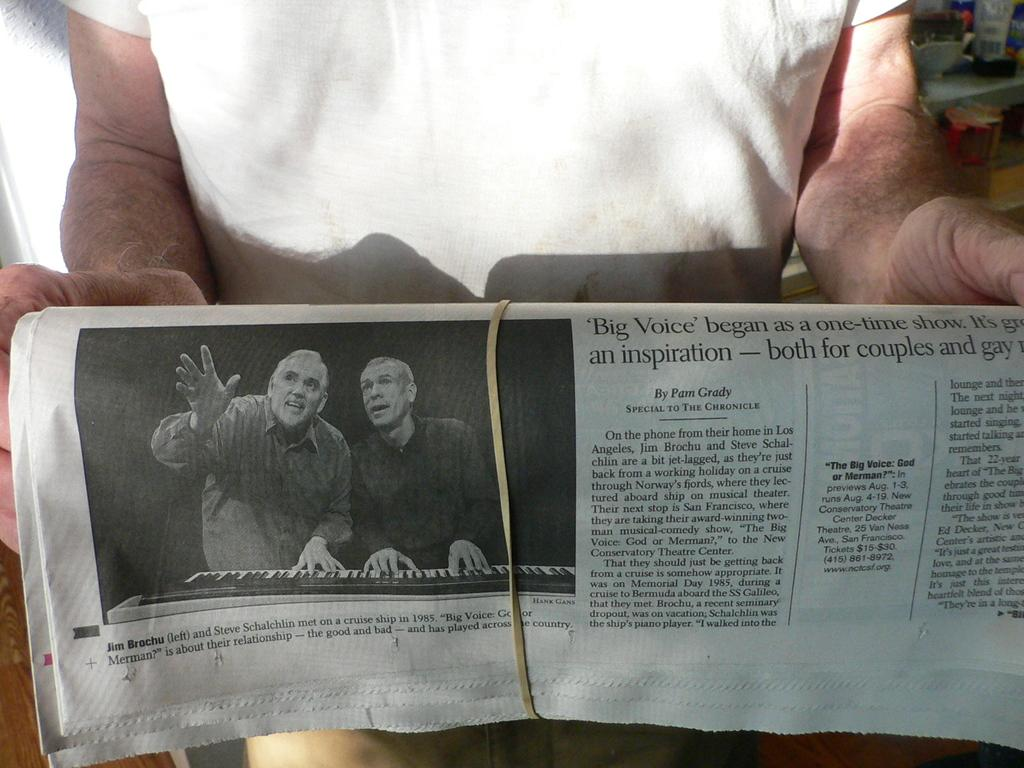<image>
Write a terse but informative summary of the picture. A person is holding a newspaper that is wrapped up with a rubber band and the head line Big Voice showing. 